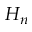Convert formula to latex. <formula><loc_0><loc_0><loc_500><loc_500>H _ { n }</formula> 